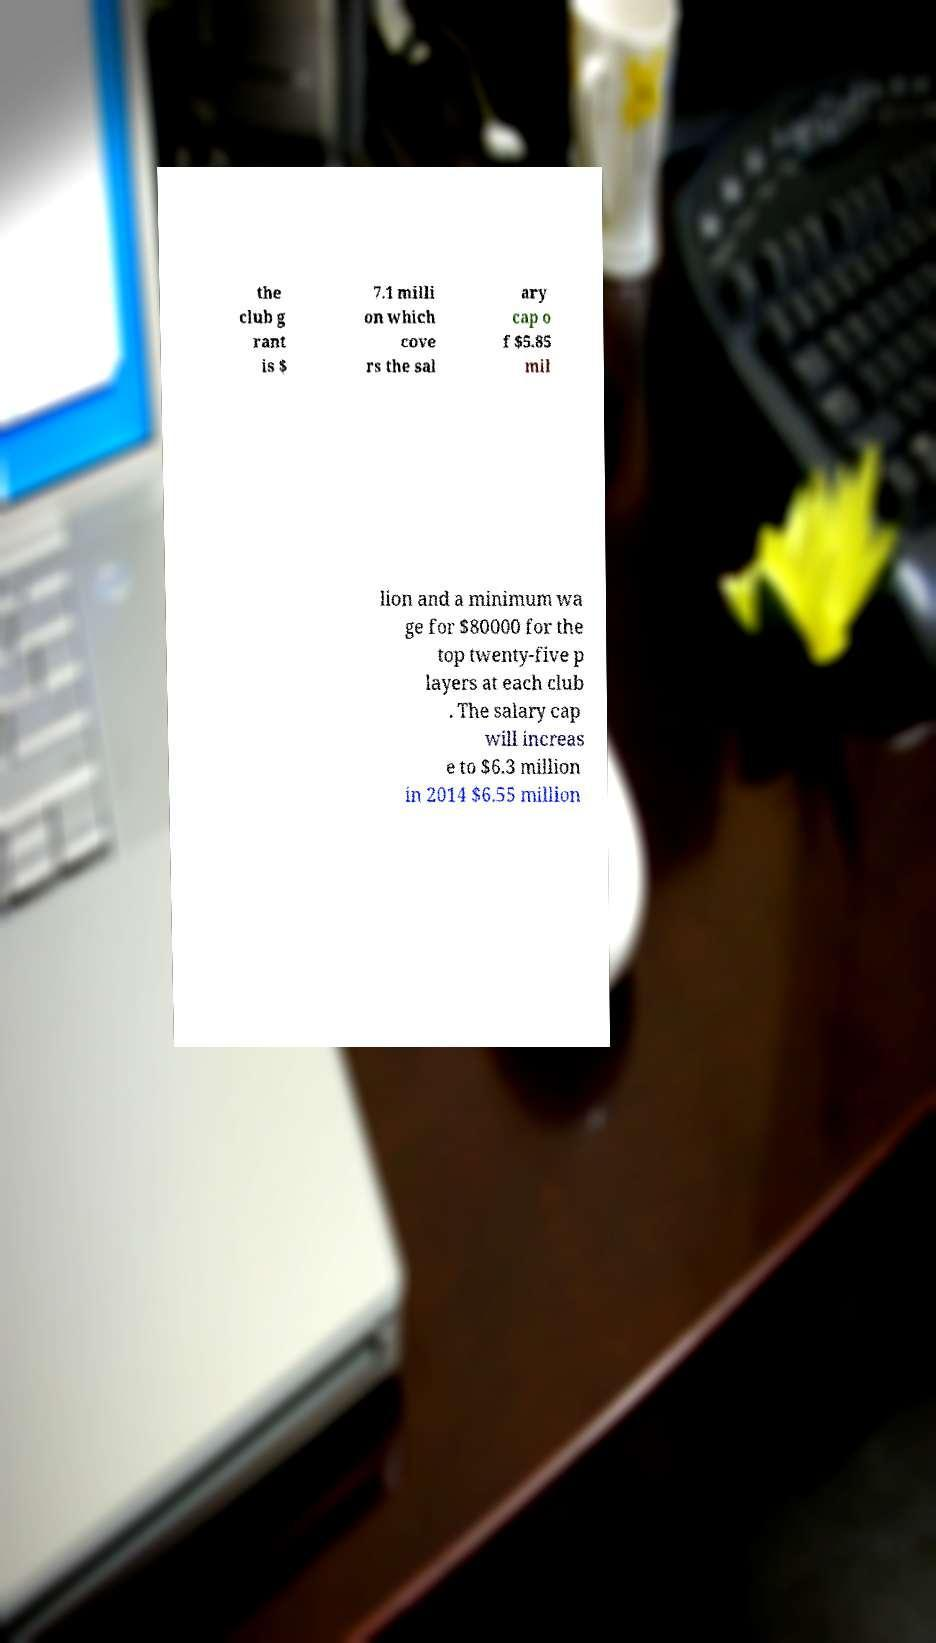There's text embedded in this image that I need extracted. Can you transcribe it verbatim? the club g rant is $ 7.1 milli on which cove rs the sal ary cap o f $5.85 mil lion and a minimum wa ge for $80000 for the top twenty-five p layers at each club . The salary cap will increas e to $6.3 million in 2014 $6.55 million 